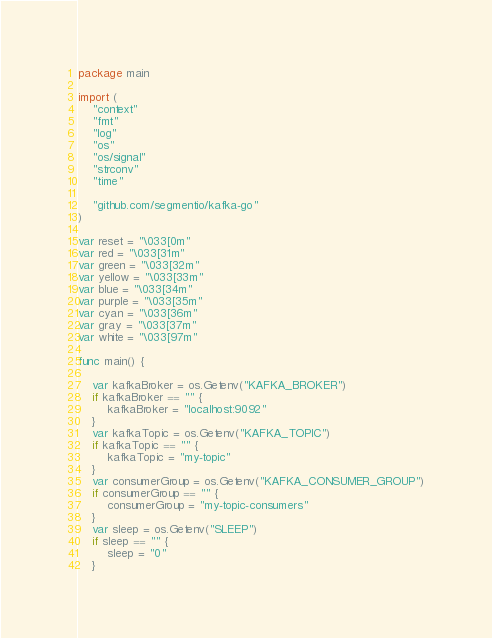Convert code to text. <code><loc_0><loc_0><loc_500><loc_500><_Go_>package main

import (
	"context"
	"fmt"
	"log"
	"os"
	"os/signal"
	"strconv"
	"time"

	"github.com/segmentio/kafka-go"
)

var reset = "\033[0m"
var red = "\033[31m"
var green = "\033[32m"
var yellow = "\033[33m"
var blue = "\033[34m"
var purple = "\033[35m"
var cyan = "\033[36m"
var gray = "\033[37m"
var white = "\033[97m"

func main() {

	var kafkaBroker = os.Getenv("KAFKA_BROKER")
	if kafkaBroker == "" {
		kafkaBroker = "localhost:9092"
	}
	var kafkaTopic = os.Getenv("KAFKA_TOPIC")
	if kafkaTopic == "" {
		kafkaTopic = "my-topic"
	}
	var consumerGroup = os.Getenv("KAFKA_CONSUMER_GROUP")
	if consumerGroup == "" {
		consumerGroup = "my-topic-consumers"
	}
	var sleep = os.Getenv("SLEEP")
	if sleep == "" {
		sleep = "0"
	}</code> 